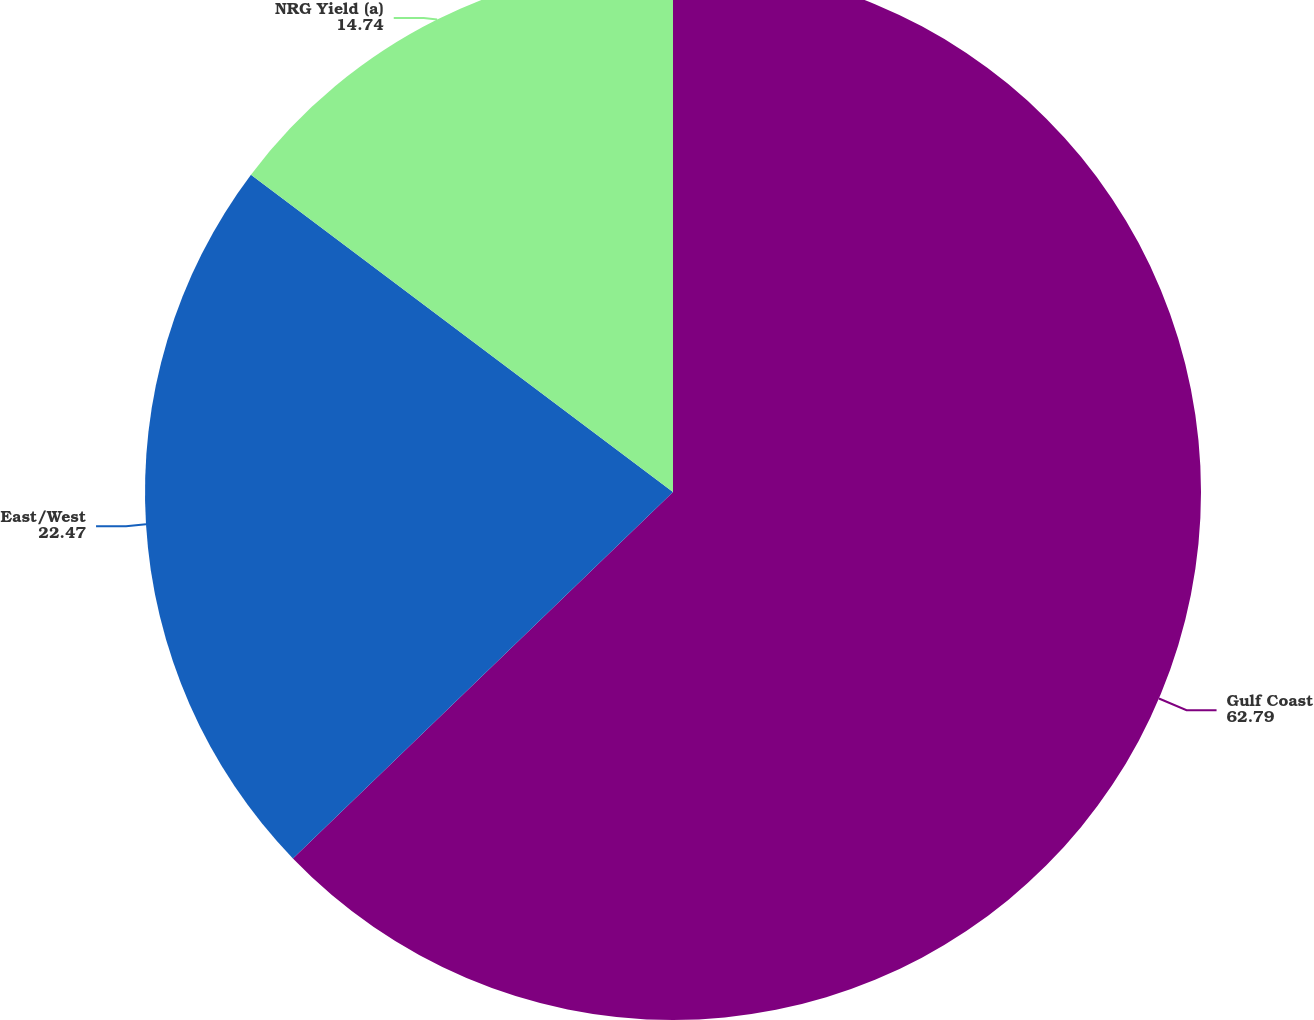<chart> <loc_0><loc_0><loc_500><loc_500><pie_chart><fcel>Gulf Coast<fcel>East/West<fcel>NRG Yield (a)<nl><fcel>62.79%<fcel>22.47%<fcel>14.74%<nl></chart> 